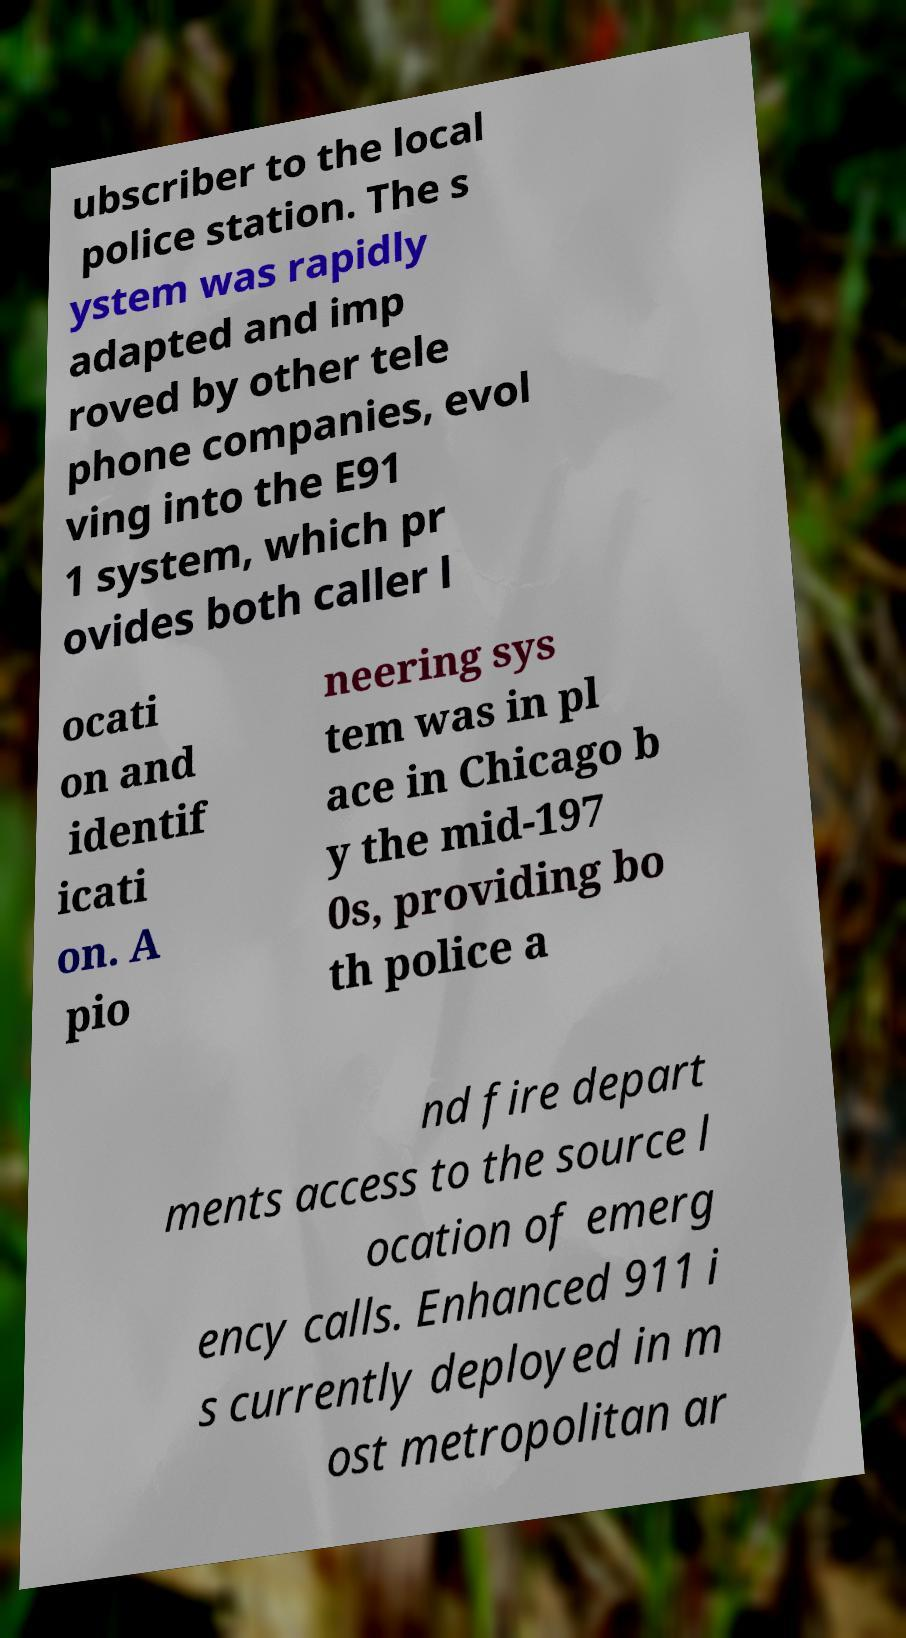Could you extract and type out the text from this image? ubscriber to the local police station. The s ystem was rapidly adapted and imp roved by other tele phone companies, evol ving into the E91 1 system, which pr ovides both caller l ocati on and identif icati on. A pio neering sys tem was in pl ace in Chicago b y the mid-197 0s, providing bo th police a nd fire depart ments access to the source l ocation of emerg ency calls. Enhanced 911 i s currently deployed in m ost metropolitan ar 